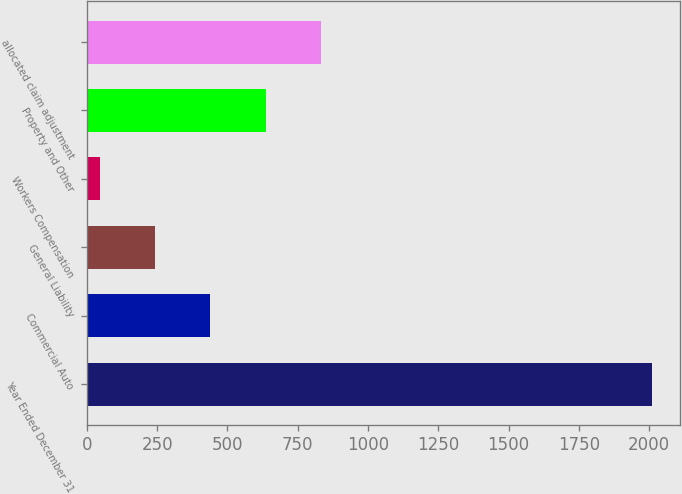Convert chart to OTSL. <chart><loc_0><loc_0><loc_500><loc_500><bar_chart><fcel>Year Ended December 31<fcel>Commercial Auto<fcel>General Liability<fcel>Workers Compensation<fcel>Property and Other<fcel>allocated claim adjustment<nl><fcel>2010<fcel>439.6<fcel>243.3<fcel>47<fcel>635.9<fcel>832.2<nl></chart> 